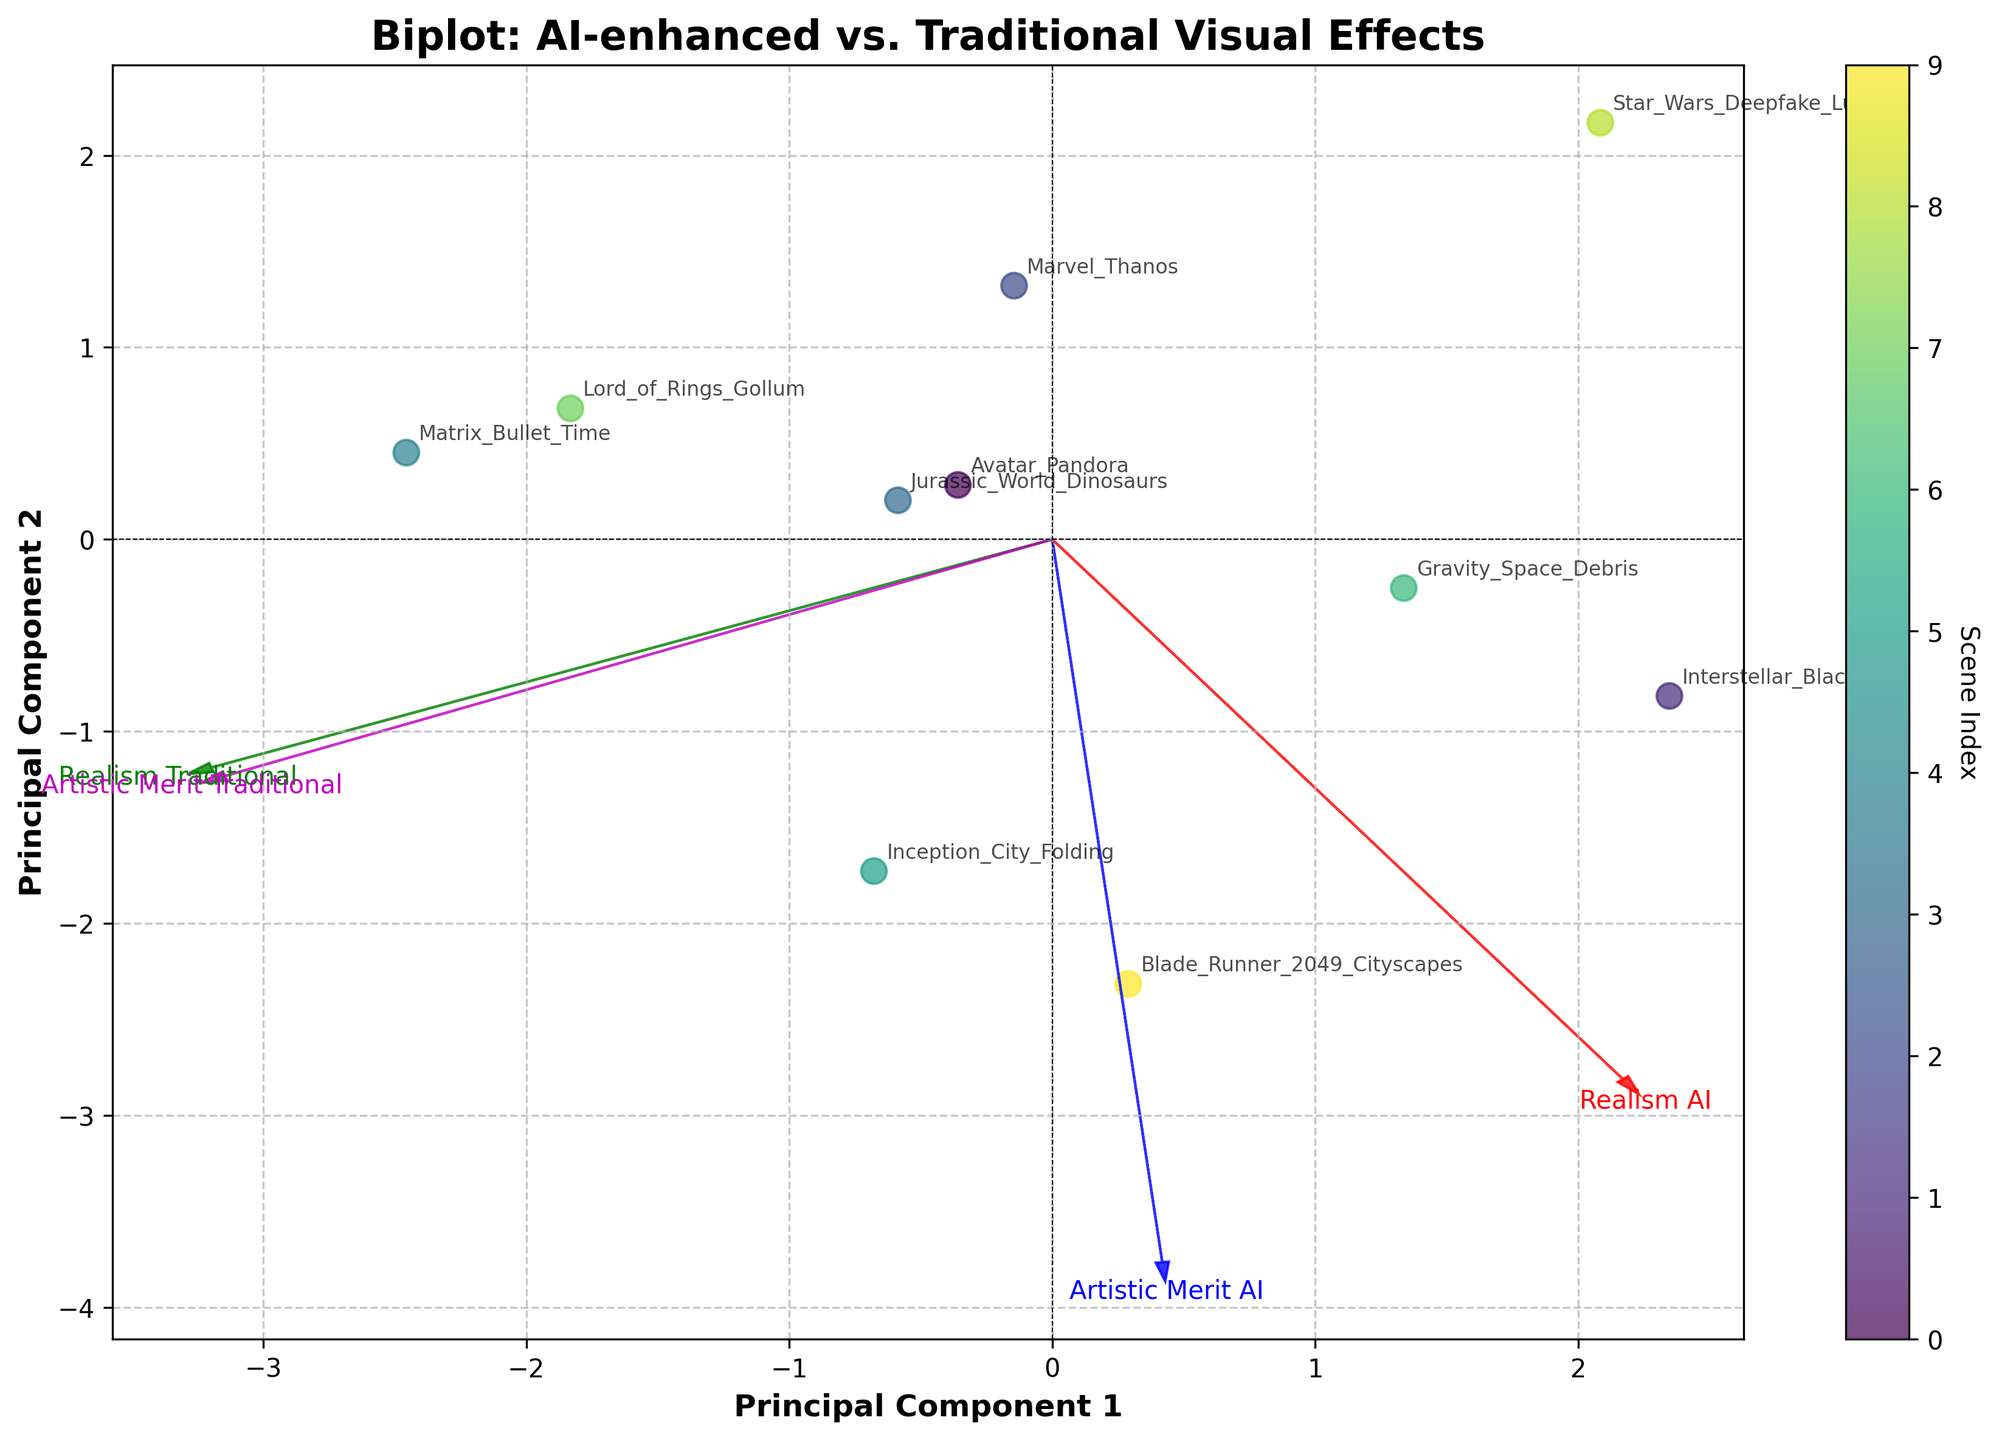What's the title of the plot? The title of the plot is usually placed at the top and clearly mentioned. By reading the title at the top of the figure, we can find out the title of the biplot.
Answer: Biplot: AI-enhanced vs. Traditional Visual Effects How many principal components are displayed in the plot? Principal components are typically represented by the axes in a biplot. This plot consists of two axes labeled as "Principal Component 1" and "Principal Component 2".
Answer: Two Which scene has the highest value along the Principal Component 1 axis? By identifying the data point farthest to the right along the Principal Component 1 axis, we can determine the scene with the highest value. The plot's annotation indicates this scene.
Answer: Blade_Runner_2049_Cityscapes What are the four features represented by the arrows? The arrows in the biplot typically represent the original features of the data. By reading the labels on the arrows, we can identify the features they represent.
Answer: Realism_AI, Realism_Traditional, Artistic_Merit_AI, Artistic_Merit_Traditional Which scene is positioned farthest in the positive direction of both Principal Component 1 and Principal Component 2? By locating the data point that is in the top-right quadrant of the plot and furthest from the origin in both axes' positive direction, we determine the scene. The plot's annotations indicate this scene.
Answer: Blade_Runner_2049_Cityscapes Which principal component has the greater variability explained by the data? By comparing the lengths of the principal component axes or the spread of the data along each axis, we can infer which principal component explains more variance. The data points are more spread out along Principal Component 1.
Answer: Principal Component 1 What does the color of the data points represent? The color of the data points usually corresponds to a specific gradient or range. By referring to the colorbar alongside the plot, we can determine that the color represents the scene index.
Answer: Scene Index Which features are most closely correlated, and how do you know? In a biplot, closely correlated features have arrows that point in similar directions and directions. By observing the orientations of the arrows, "Realism AI" and "Artistic Merit AI" point in nearly the same direction.
Answer: Realism_Ai and Artistic_Merit_AI What scene has the lowest value on the Principal Component 2 axis? By locating the data point farthest down along the Principal Component 2 axis, we can determine this scene. The plot's annotation will identify this scene.
Answer: Star_Wars_Deepfake_Luke 